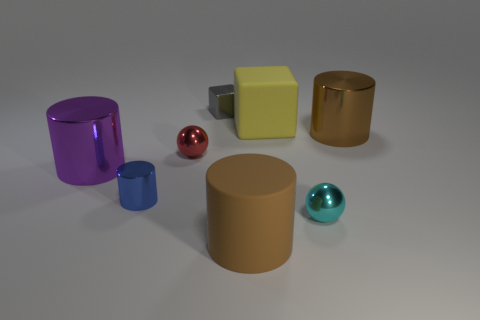Subtract all purple metallic cylinders. How many cylinders are left? 3 Subtract 1 balls. How many balls are left? 1 Subtract all cyan blocks. How many brown cylinders are left? 2 Add 7 tiny red things. How many tiny red things exist? 8 Add 2 blue things. How many objects exist? 10 Subtract all yellow blocks. How many blocks are left? 1 Subtract 0 blue cubes. How many objects are left? 8 Subtract all balls. How many objects are left? 6 Subtract all gray cylinders. Subtract all purple balls. How many cylinders are left? 4 Subtract all cubes. Subtract all big brown cylinders. How many objects are left? 4 